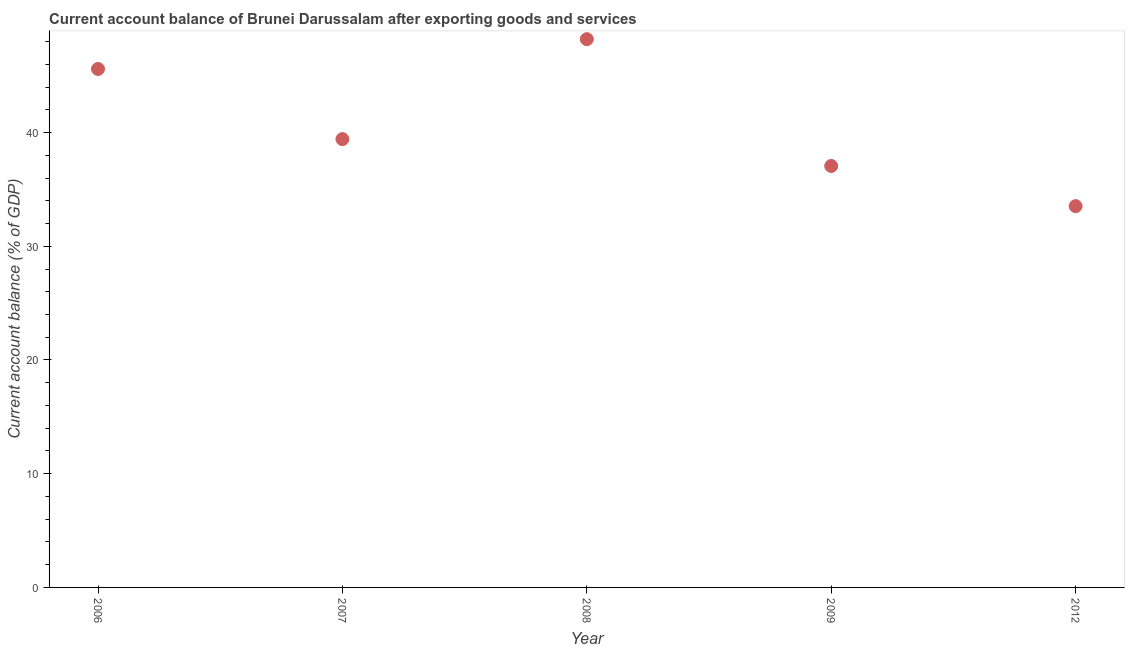What is the current account balance in 2012?
Keep it short and to the point. 33.53. Across all years, what is the maximum current account balance?
Offer a very short reply. 48.21. Across all years, what is the minimum current account balance?
Provide a succinct answer. 33.53. What is the sum of the current account balance?
Keep it short and to the point. 203.81. What is the difference between the current account balance in 2006 and 2008?
Keep it short and to the point. -2.62. What is the average current account balance per year?
Ensure brevity in your answer.  40.76. What is the median current account balance?
Your response must be concise. 39.42. In how many years, is the current account balance greater than 24 %?
Provide a short and direct response. 5. What is the ratio of the current account balance in 2007 to that in 2008?
Give a very brief answer. 0.82. What is the difference between the highest and the second highest current account balance?
Offer a very short reply. 2.62. What is the difference between the highest and the lowest current account balance?
Provide a short and direct response. 14.68. In how many years, is the current account balance greater than the average current account balance taken over all years?
Keep it short and to the point. 2. Does the graph contain grids?
Offer a terse response. No. What is the title of the graph?
Provide a succinct answer. Current account balance of Brunei Darussalam after exporting goods and services. What is the label or title of the X-axis?
Offer a terse response. Year. What is the label or title of the Y-axis?
Ensure brevity in your answer.  Current account balance (% of GDP). What is the Current account balance (% of GDP) in 2006?
Keep it short and to the point. 45.59. What is the Current account balance (% of GDP) in 2007?
Your answer should be compact. 39.42. What is the Current account balance (% of GDP) in 2008?
Provide a short and direct response. 48.21. What is the Current account balance (% of GDP) in 2009?
Make the answer very short. 37.06. What is the Current account balance (% of GDP) in 2012?
Provide a short and direct response. 33.53. What is the difference between the Current account balance (% of GDP) in 2006 and 2007?
Your answer should be compact. 6.17. What is the difference between the Current account balance (% of GDP) in 2006 and 2008?
Keep it short and to the point. -2.62. What is the difference between the Current account balance (% of GDP) in 2006 and 2009?
Keep it short and to the point. 8.53. What is the difference between the Current account balance (% of GDP) in 2006 and 2012?
Ensure brevity in your answer.  12.06. What is the difference between the Current account balance (% of GDP) in 2007 and 2008?
Offer a very short reply. -8.79. What is the difference between the Current account balance (% of GDP) in 2007 and 2009?
Provide a succinct answer. 2.36. What is the difference between the Current account balance (% of GDP) in 2007 and 2012?
Offer a terse response. 5.9. What is the difference between the Current account balance (% of GDP) in 2008 and 2009?
Keep it short and to the point. 11.15. What is the difference between the Current account balance (% of GDP) in 2008 and 2012?
Your response must be concise. 14.68. What is the difference between the Current account balance (% of GDP) in 2009 and 2012?
Keep it short and to the point. 3.53. What is the ratio of the Current account balance (% of GDP) in 2006 to that in 2007?
Your answer should be compact. 1.16. What is the ratio of the Current account balance (% of GDP) in 2006 to that in 2008?
Ensure brevity in your answer.  0.95. What is the ratio of the Current account balance (% of GDP) in 2006 to that in 2009?
Your response must be concise. 1.23. What is the ratio of the Current account balance (% of GDP) in 2006 to that in 2012?
Your answer should be compact. 1.36. What is the ratio of the Current account balance (% of GDP) in 2007 to that in 2008?
Offer a very short reply. 0.82. What is the ratio of the Current account balance (% of GDP) in 2007 to that in 2009?
Provide a succinct answer. 1.06. What is the ratio of the Current account balance (% of GDP) in 2007 to that in 2012?
Keep it short and to the point. 1.18. What is the ratio of the Current account balance (% of GDP) in 2008 to that in 2009?
Provide a short and direct response. 1.3. What is the ratio of the Current account balance (% of GDP) in 2008 to that in 2012?
Ensure brevity in your answer.  1.44. What is the ratio of the Current account balance (% of GDP) in 2009 to that in 2012?
Make the answer very short. 1.1. 